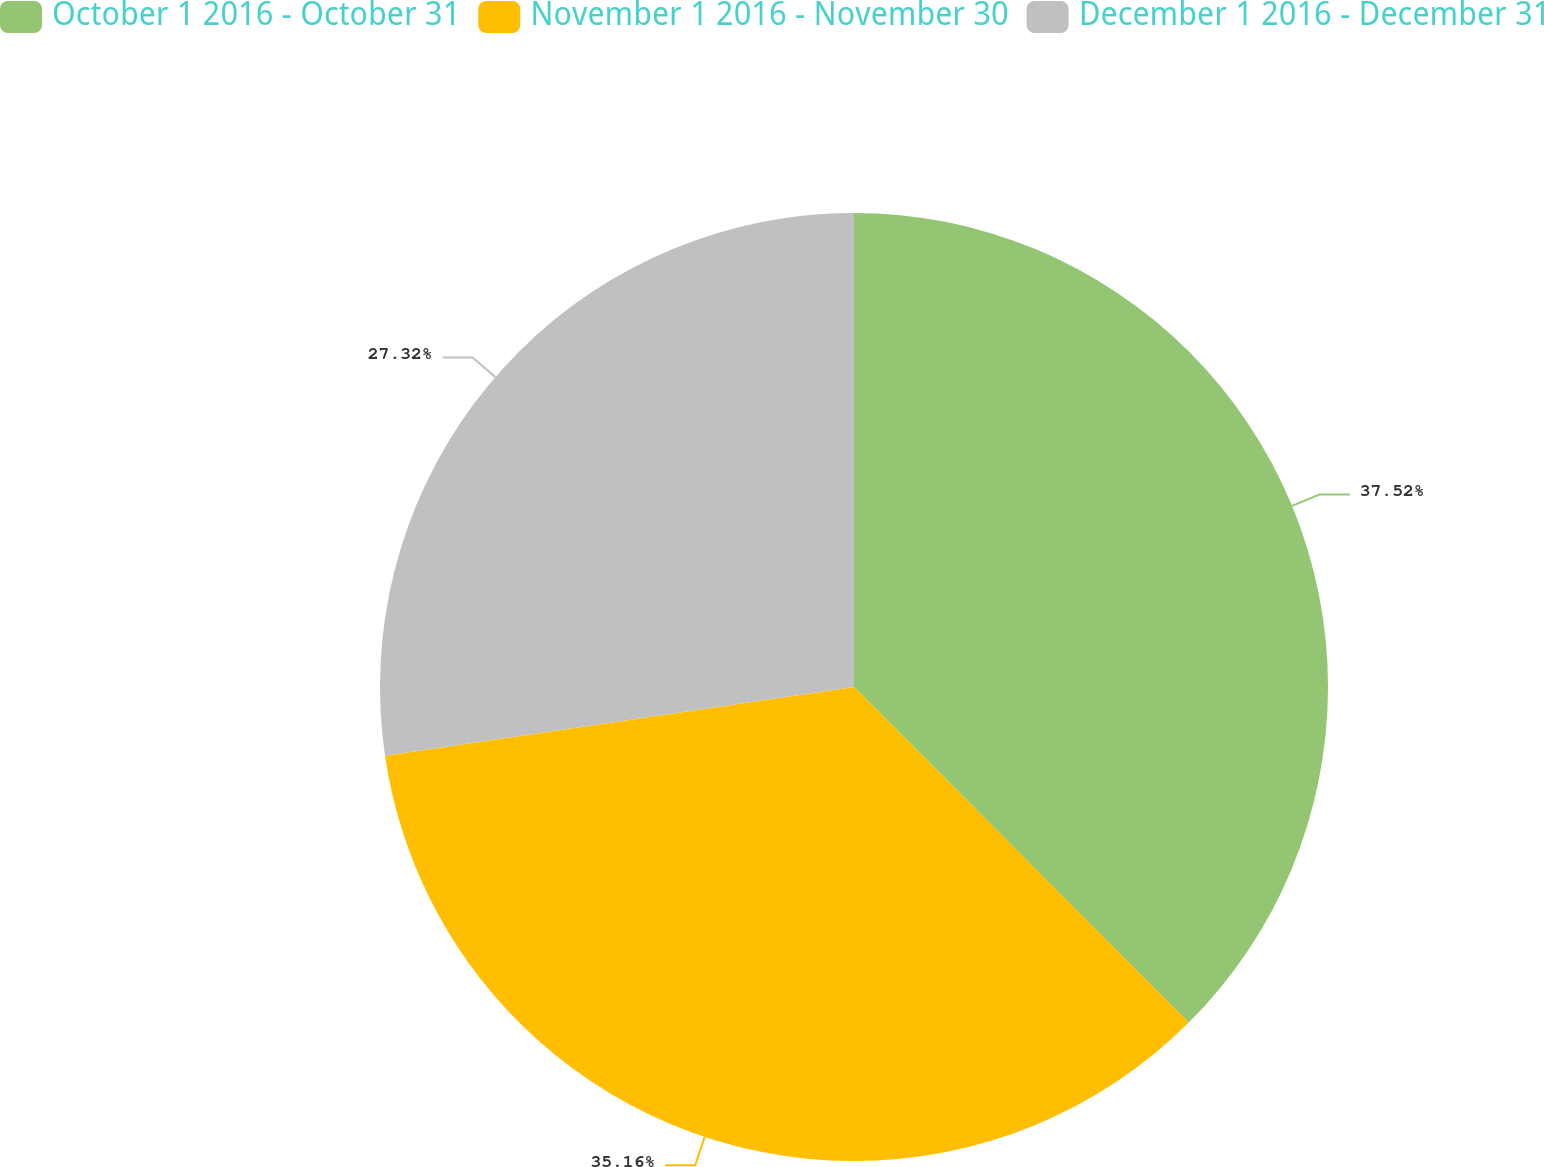Convert chart. <chart><loc_0><loc_0><loc_500><loc_500><pie_chart><fcel>October 1 2016 - October 31<fcel>November 1 2016 - November 30<fcel>December 1 2016 - December 31<nl><fcel>37.52%<fcel>35.16%<fcel>27.32%<nl></chart> 